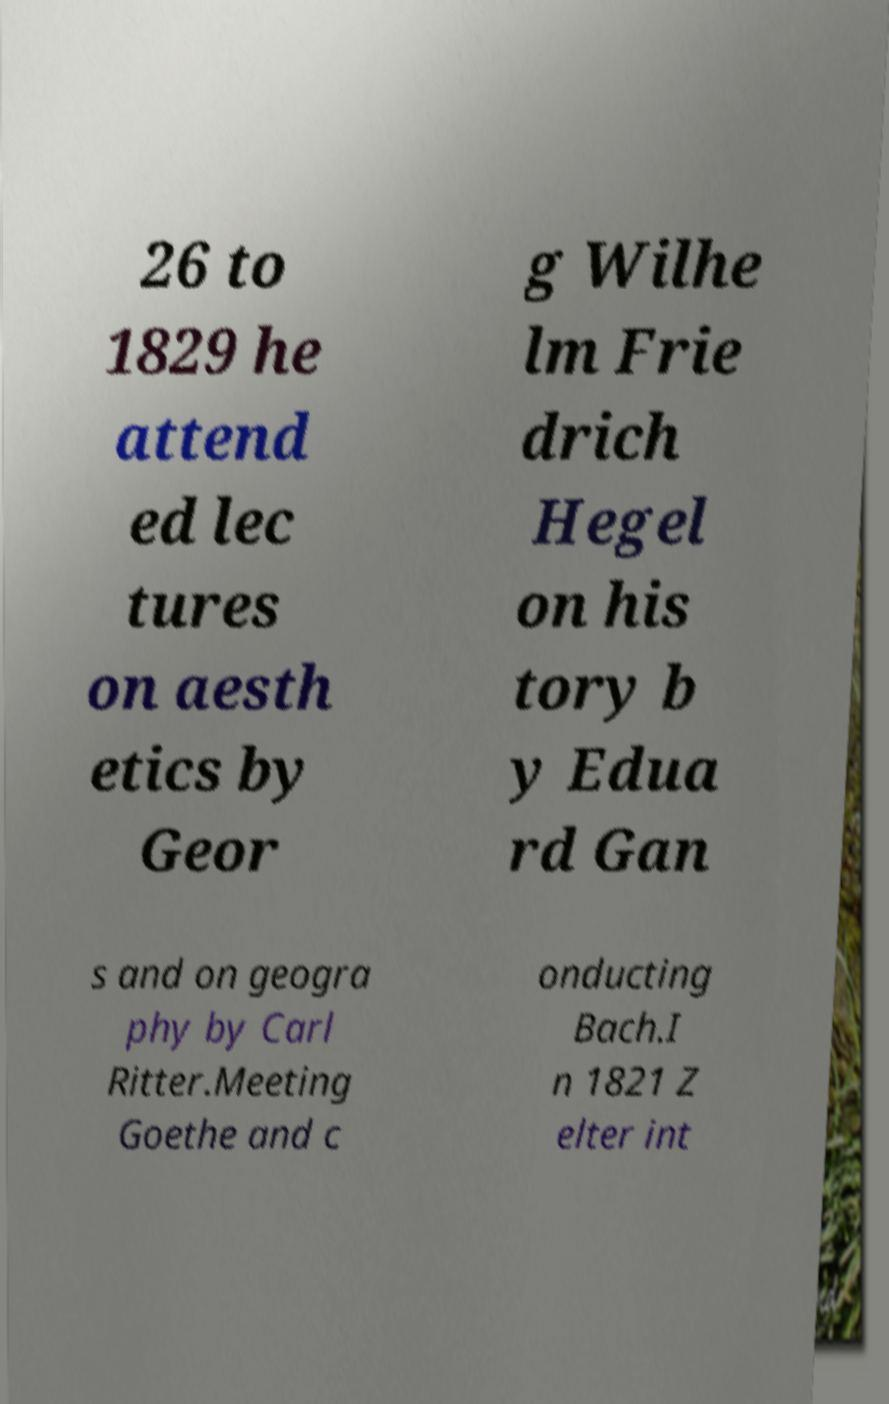I need the written content from this picture converted into text. Can you do that? 26 to 1829 he attend ed lec tures on aesth etics by Geor g Wilhe lm Frie drich Hegel on his tory b y Edua rd Gan s and on geogra phy by Carl Ritter.Meeting Goethe and c onducting Bach.I n 1821 Z elter int 